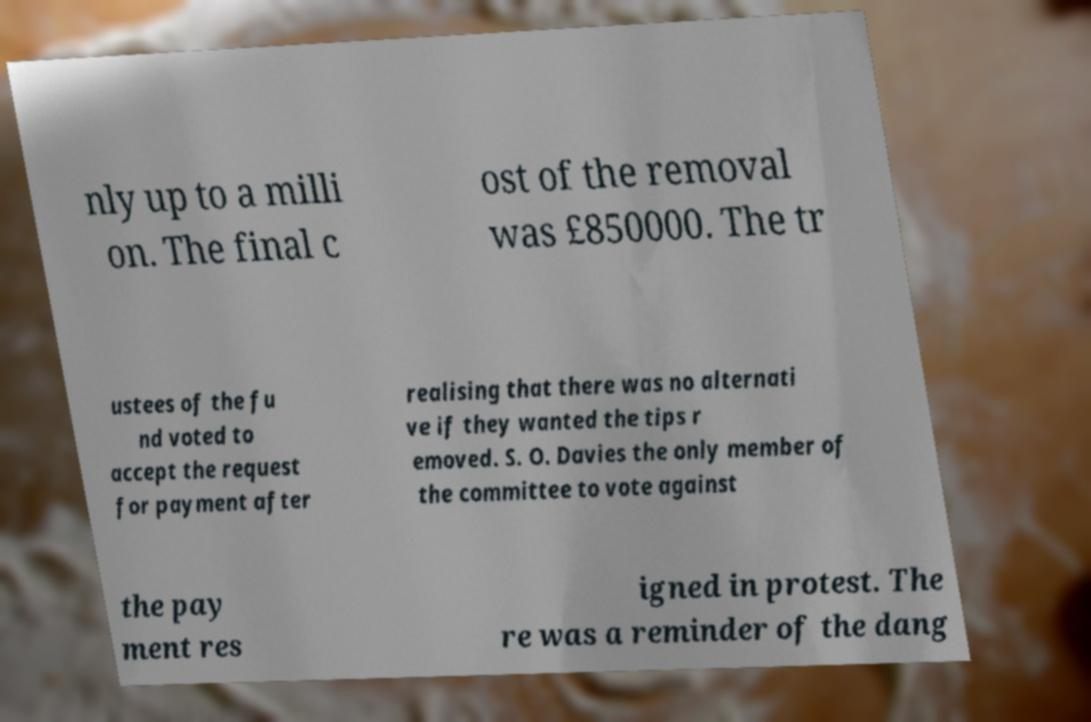Could you extract and type out the text from this image? nly up to a milli on. The final c ost of the removal was £850000. The tr ustees of the fu nd voted to accept the request for payment after realising that there was no alternati ve if they wanted the tips r emoved. S. O. Davies the only member of the committee to vote against the pay ment res igned in protest. The re was a reminder of the dang 